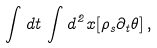<formula> <loc_0><loc_0><loc_500><loc_500>\int d t \, \int d ^ { 2 } x [ \rho _ { s } \partial _ { t } \theta ] \, ,</formula> 